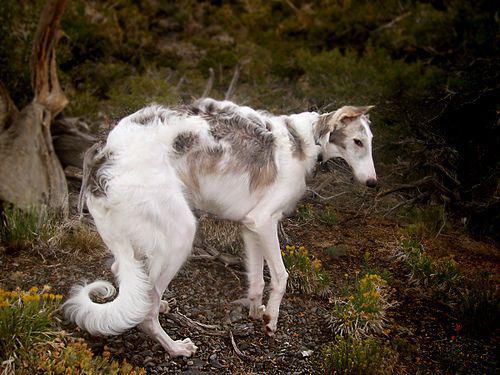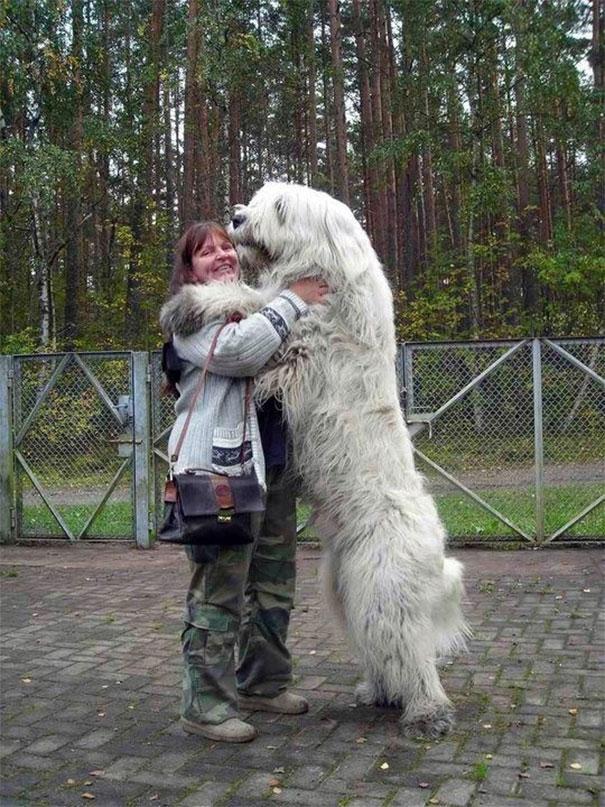The first image is the image on the left, the second image is the image on the right. For the images shown, is this caption "A person is standing in the center of the scene, interacting with at least one all-white dog." true? Answer yes or no. Yes. The first image is the image on the left, the second image is the image on the right. Considering the images on both sides, is "A dog is being touched by a human in one of the images." valid? Answer yes or no. Yes. 